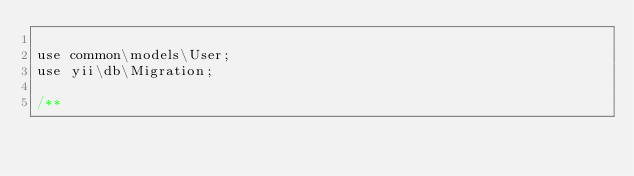Convert code to text. <code><loc_0><loc_0><loc_500><loc_500><_PHP_>
use common\models\User;
use yii\db\Migration;

/**</code> 